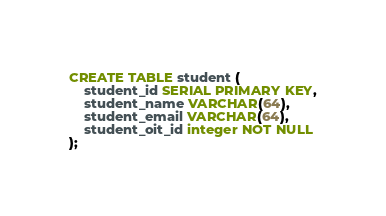Convert code to text. <code><loc_0><loc_0><loc_500><loc_500><_SQL_>CREATE TABLE student (
	student_id SERIAL PRIMARY KEY,
	student_name VARCHAR(64),
	student_email VARCHAR(64),
	student_oit_id integer NOT NULL
);</code> 